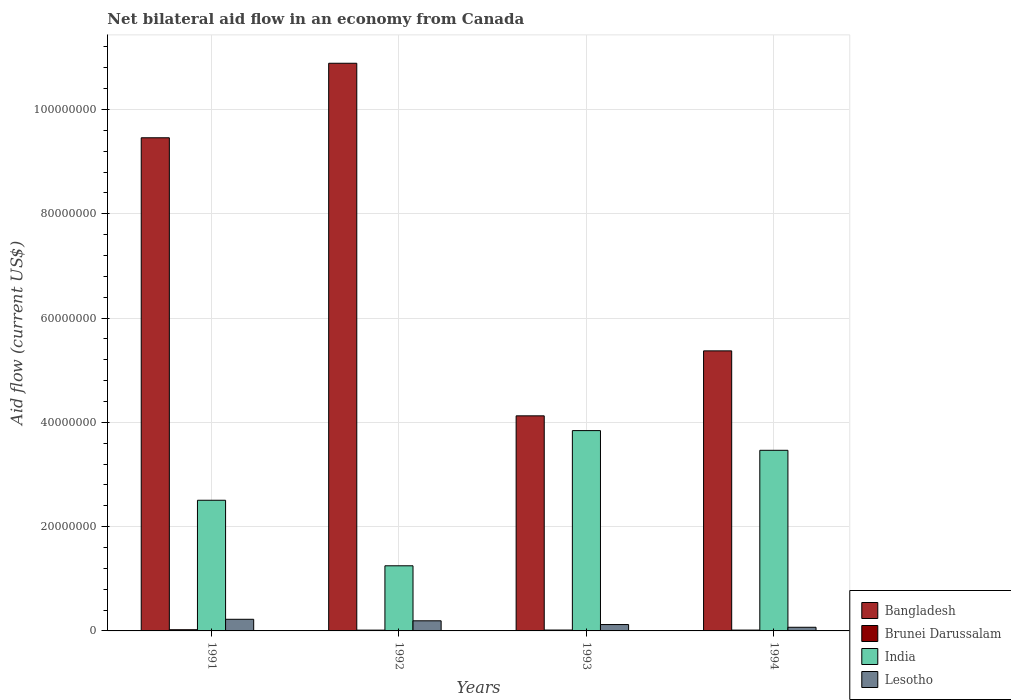How many different coloured bars are there?
Your answer should be very brief. 4. Are the number of bars per tick equal to the number of legend labels?
Ensure brevity in your answer.  Yes. How many bars are there on the 2nd tick from the right?
Make the answer very short. 4. What is the label of the 2nd group of bars from the left?
Provide a short and direct response. 1992. In how many cases, is the number of bars for a given year not equal to the number of legend labels?
Offer a terse response. 0. What is the net bilateral aid flow in Lesotho in 1993?
Provide a succinct answer. 1.22e+06. Across all years, what is the maximum net bilateral aid flow in Lesotho?
Offer a terse response. 2.23e+06. Across all years, what is the minimum net bilateral aid flow in Bangladesh?
Ensure brevity in your answer.  4.12e+07. In which year was the net bilateral aid flow in Bangladesh maximum?
Provide a succinct answer. 1992. What is the total net bilateral aid flow in Brunei Darussalam in the graph?
Provide a succinct answer. 7.10e+05. What is the difference between the net bilateral aid flow in Lesotho in 1991 and that in 1992?
Give a very brief answer. 2.90e+05. What is the difference between the net bilateral aid flow in Brunei Darussalam in 1993 and the net bilateral aid flow in Bangladesh in 1994?
Give a very brief answer. -5.35e+07. What is the average net bilateral aid flow in Bangladesh per year?
Give a very brief answer. 7.46e+07. In the year 1993, what is the difference between the net bilateral aid flow in Bangladesh and net bilateral aid flow in India?
Your answer should be compact. 2.83e+06. What is the ratio of the net bilateral aid flow in India in 1991 to that in 1992?
Your response must be concise. 2.01. What is the difference between the highest and the second highest net bilateral aid flow in Bangladesh?
Offer a terse response. 1.43e+07. What is the difference between the highest and the lowest net bilateral aid flow in Bangladesh?
Offer a terse response. 6.76e+07. Is the sum of the net bilateral aid flow in India in 1991 and 1994 greater than the maximum net bilateral aid flow in Lesotho across all years?
Provide a succinct answer. Yes. Is it the case that in every year, the sum of the net bilateral aid flow in Lesotho and net bilateral aid flow in Bangladesh is greater than the sum of net bilateral aid flow in Brunei Darussalam and net bilateral aid flow in India?
Offer a terse response. No. What does the 3rd bar from the right in 1991 represents?
Offer a very short reply. Brunei Darussalam. Are all the bars in the graph horizontal?
Provide a succinct answer. No. What is the difference between two consecutive major ticks on the Y-axis?
Your answer should be very brief. 2.00e+07. Does the graph contain any zero values?
Offer a terse response. No. Does the graph contain grids?
Offer a very short reply. Yes. Where does the legend appear in the graph?
Provide a short and direct response. Bottom right. What is the title of the graph?
Offer a very short reply. Net bilateral aid flow in an economy from Canada. What is the label or title of the X-axis?
Provide a succinct answer. Years. What is the label or title of the Y-axis?
Provide a succinct answer. Aid flow (current US$). What is the Aid flow (current US$) in Bangladesh in 1991?
Make the answer very short. 9.46e+07. What is the Aid flow (current US$) in Brunei Darussalam in 1991?
Provide a succinct answer. 2.30e+05. What is the Aid flow (current US$) in India in 1991?
Offer a terse response. 2.51e+07. What is the Aid flow (current US$) of Lesotho in 1991?
Keep it short and to the point. 2.23e+06. What is the Aid flow (current US$) of Bangladesh in 1992?
Your answer should be compact. 1.09e+08. What is the Aid flow (current US$) of Brunei Darussalam in 1992?
Keep it short and to the point. 1.50e+05. What is the Aid flow (current US$) in India in 1992?
Keep it short and to the point. 1.25e+07. What is the Aid flow (current US$) of Lesotho in 1992?
Your answer should be very brief. 1.94e+06. What is the Aid flow (current US$) in Bangladesh in 1993?
Make the answer very short. 4.12e+07. What is the Aid flow (current US$) of Brunei Darussalam in 1993?
Offer a very short reply. 1.70e+05. What is the Aid flow (current US$) in India in 1993?
Offer a terse response. 3.84e+07. What is the Aid flow (current US$) in Lesotho in 1993?
Offer a terse response. 1.22e+06. What is the Aid flow (current US$) of Bangladesh in 1994?
Offer a terse response. 5.37e+07. What is the Aid flow (current US$) of Brunei Darussalam in 1994?
Offer a terse response. 1.60e+05. What is the Aid flow (current US$) of India in 1994?
Offer a very short reply. 3.46e+07. Across all years, what is the maximum Aid flow (current US$) of Bangladesh?
Provide a short and direct response. 1.09e+08. Across all years, what is the maximum Aid flow (current US$) of India?
Make the answer very short. 3.84e+07. Across all years, what is the maximum Aid flow (current US$) of Lesotho?
Make the answer very short. 2.23e+06. Across all years, what is the minimum Aid flow (current US$) of Bangladesh?
Offer a terse response. 4.12e+07. Across all years, what is the minimum Aid flow (current US$) of Brunei Darussalam?
Your response must be concise. 1.50e+05. Across all years, what is the minimum Aid flow (current US$) in India?
Offer a terse response. 1.25e+07. What is the total Aid flow (current US$) of Bangladesh in the graph?
Provide a succinct answer. 2.98e+08. What is the total Aid flow (current US$) of Brunei Darussalam in the graph?
Your response must be concise. 7.10e+05. What is the total Aid flow (current US$) in India in the graph?
Give a very brief answer. 1.11e+08. What is the total Aid flow (current US$) of Lesotho in the graph?
Give a very brief answer. 6.09e+06. What is the difference between the Aid flow (current US$) in Bangladesh in 1991 and that in 1992?
Your answer should be compact. -1.43e+07. What is the difference between the Aid flow (current US$) of India in 1991 and that in 1992?
Give a very brief answer. 1.26e+07. What is the difference between the Aid flow (current US$) of Lesotho in 1991 and that in 1992?
Offer a very short reply. 2.90e+05. What is the difference between the Aid flow (current US$) in Bangladesh in 1991 and that in 1993?
Provide a short and direct response. 5.33e+07. What is the difference between the Aid flow (current US$) in Brunei Darussalam in 1991 and that in 1993?
Your answer should be very brief. 6.00e+04. What is the difference between the Aid flow (current US$) of India in 1991 and that in 1993?
Provide a short and direct response. -1.34e+07. What is the difference between the Aid flow (current US$) of Lesotho in 1991 and that in 1993?
Keep it short and to the point. 1.01e+06. What is the difference between the Aid flow (current US$) in Bangladesh in 1991 and that in 1994?
Your answer should be very brief. 4.09e+07. What is the difference between the Aid flow (current US$) of Brunei Darussalam in 1991 and that in 1994?
Your answer should be very brief. 7.00e+04. What is the difference between the Aid flow (current US$) of India in 1991 and that in 1994?
Your answer should be compact. -9.58e+06. What is the difference between the Aid flow (current US$) of Lesotho in 1991 and that in 1994?
Provide a short and direct response. 1.53e+06. What is the difference between the Aid flow (current US$) in Bangladesh in 1992 and that in 1993?
Give a very brief answer. 6.76e+07. What is the difference between the Aid flow (current US$) of Brunei Darussalam in 1992 and that in 1993?
Your answer should be very brief. -2.00e+04. What is the difference between the Aid flow (current US$) of India in 1992 and that in 1993?
Provide a succinct answer. -2.59e+07. What is the difference between the Aid flow (current US$) of Lesotho in 1992 and that in 1993?
Make the answer very short. 7.20e+05. What is the difference between the Aid flow (current US$) in Bangladesh in 1992 and that in 1994?
Make the answer very short. 5.52e+07. What is the difference between the Aid flow (current US$) in India in 1992 and that in 1994?
Offer a terse response. -2.22e+07. What is the difference between the Aid flow (current US$) of Lesotho in 1992 and that in 1994?
Offer a very short reply. 1.24e+06. What is the difference between the Aid flow (current US$) in Bangladesh in 1993 and that in 1994?
Your response must be concise. -1.25e+07. What is the difference between the Aid flow (current US$) in India in 1993 and that in 1994?
Offer a terse response. 3.78e+06. What is the difference between the Aid flow (current US$) in Lesotho in 1993 and that in 1994?
Keep it short and to the point. 5.20e+05. What is the difference between the Aid flow (current US$) in Bangladesh in 1991 and the Aid flow (current US$) in Brunei Darussalam in 1992?
Make the answer very short. 9.44e+07. What is the difference between the Aid flow (current US$) of Bangladesh in 1991 and the Aid flow (current US$) of India in 1992?
Provide a succinct answer. 8.21e+07. What is the difference between the Aid flow (current US$) in Bangladesh in 1991 and the Aid flow (current US$) in Lesotho in 1992?
Provide a short and direct response. 9.26e+07. What is the difference between the Aid flow (current US$) in Brunei Darussalam in 1991 and the Aid flow (current US$) in India in 1992?
Your answer should be compact. -1.23e+07. What is the difference between the Aid flow (current US$) in Brunei Darussalam in 1991 and the Aid flow (current US$) in Lesotho in 1992?
Provide a succinct answer. -1.71e+06. What is the difference between the Aid flow (current US$) in India in 1991 and the Aid flow (current US$) in Lesotho in 1992?
Make the answer very short. 2.31e+07. What is the difference between the Aid flow (current US$) of Bangladesh in 1991 and the Aid flow (current US$) of Brunei Darussalam in 1993?
Give a very brief answer. 9.44e+07. What is the difference between the Aid flow (current US$) in Bangladesh in 1991 and the Aid flow (current US$) in India in 1993?
Ensure brevity in your answer.  5.62e+07. What is the difference between the Aid flow (current US$) in Bangladesh in 1991 and the Aid flow (current US$) in Lesotho in 1993?
Provide a succinct answer. 9.34e+07. What is the difference between the Aid flow (current US$) in Brunei Darussalam in 1991 and the Aid flow (current US$) in India in 1993?
Your answer should be very brief. -3.82e+07. What is the difference between the Aid flow (current US$) in Brunei Darussalam in 1991 and the Aid flow (current US$) in Lesotho in 1993?
Make the answer very short. -9.90e+05. What is the difference between the Aid flow (current US$) of India in 1991 and the Aid flow (current US$) of Lesotho in 1993?
Ensure brevity in your answer.  2.38e+07. What is the difference between the Aid flow (current US$) in Bangladesh in 1991 and the Aid flow (current US$) in Brunei Darussalam in 1994?
Give a very brief answer. 9.44e+07. What is the difference between the Aid flow (current US$) in Bangladesh in 1991 and the Aid flow (current US$) in India in 1994?
Give a very brief answer. 5.99e+07. What is the difference between the Aid flow (current US$) of Bangladesh in 1991 and the Aid flow (current US$) of Lesotho in 1994?
Provide a succinct answer. 9.39e+07. What is the difference between the Aid flow (current US$) of Brunei Darussalam in 1991 and the Aid flow (current US$) of India in 1994?
Make the answer very short. -3.44e+07. What is the difference between the Aid flow (current US$) in Brunei Darussalam in 1991 and the Aid flow (current US$) in Lesotho in 1994?
Offer a terse response. -4.70e+05. What is the difference between the Aid flow (current US$) in India in 1991 and the Aid flow (current US$) in Lesotho in 1994?
Ensure brevity in your answer.  2.44e+07. What is the difference between the Aid flow (current US$) of Bangladesh in 1992 and the Aid flow (current US$) of Brunei Darussalam in 1993?
Make the answer very short. 1.09e+08. What is the difference between the Aid flow (current US$) of Bangladesh in 1992 and the Aid flow (current US$) of India in 1993?
Make the answer very short. 7.04e+07. What is the difference between the Aid flow (current US$) in Bangladesh in 1992 and the Aid flow (current US$) in Lesotho in 1993?
Your response must be concise. 1.08e+08. What is the difference between the Aid flow (current US$) in Brunei Darussalam in 1992 and the Aid flow (current US$) in India in 1993?
Provide a succinct answer. -3.83e+07. What is the difference between the Aid flow (current US$) of Brunei Darussalam in 1992 and the Aid flow (current US$) of Lesotho in 1993?
Make the answer very short. -1.07e+06. What is the difference between the Aid flow (current US$) in India in 1992 and the Aid flow (current US$) in Lesotho in 1993?
Give a very brief answer. 1.13e+07. What is the difference between the Aid flow (current US$) in Bangladesh in 1992 and the Aid flow (current US$) in Brunei Darussalam in 1994?
Your response must be concise. 1.09e+08. What is the difference between the Aid flow (current US$) in Bangladesh in 1992 and the Aid flow (current US$) in India in 1994?
Your answer should be very brief. 7.42e+07. What is the difference between the Aid flow (current US$) of Bangladesh in 1992 and the Aid flow (current US$) of Lesotho in 1994?
Ensure brevity in your answer.  1.08e+08. What is the difference between the Aid flow (current US$) in Brunei Darussalam in 1992 and the Aid flow (current US$) in India in 1994?
Offer a very short reply. -3.45e+07. What is the difference between the Aid flow (current US$) of Brunei Darussalam in 1992 and the Aid flow (current US$) of Lesotho in 1994?
Provide a succinct answer. -5.50e+05. What is the difference between the Aid flow (current US$) in India in 1992 and the Aid flow (current US$) in Lesotho in 1994?
Ensure brevity in your answer.  1.18e+07. What is the difference between the Aid flow (current US$) of Bangladesh in 1993 and the Aid flow (current US$) of Brunei Darussalam in 1994?
Your answer should be compact. 4.11e+07. What is the difference between the Aid flow (current US$) in Bangladesh in 1993 and the Aid flow (current US$) in India in 1994?
Your answer should be compact. 6.61e+06. What is the difference between the Aid flow (current US$) of Bangladesh in 1993 and the Aid flow (current US$) of Lesotho in 1994?
Provide a succinct answer. 4.06e+07. What is the difference between the Aid flow (current US$) of Brunei Darussalam in 1993 and the Aid flow (current US$) of India in 1994?
Offer a very short reply. -3.45e+07. What is the difference between the Aid flow (current US$) of Brunei Darussalam in 1993 and the Aid flow (current US$) of Lesotho in 1994?
Give a very brief answer. -5.30e+05. What is the difference between the Aid flow (current US$) in India in 1993 and the Aid flow (current US$) in Lesotho in 1994?
Give a very brief answer. 3.77e+07. What is the average Aid flow (current US$) in Bangladesh per year?
Your answer should be compact. 7.46e+07. What is the average Aid flow (current US$) in Brunei Darussalam per year?
Provide a succinct answer. 1.78e+05. What is the average Aid flow (current US$) of India per year?
Provide a short and direct response. 2.77e+07. What is the average Aid flow (current US$) of Lesotho per year?
Offer a very short reply. 1.52e+06. In the year 1991, what is the difference between the Aid flow (current US$) in Bangladesh and Aid flow (current US$) in Brunei Darussalam?
Keep it short and to the point. 9.44e+07. In the year 1991, what is the difference between the Aid flow (current US$) of Bangladesh and Aid flow (current US$) of India?
Offer a terse response. 6.95e+07. In the year 1991, what is the difference between the Aid flow (current US$) of Bangladesh and Aid flow (current US$) of Lesotho?
Offer a very short reply. 9.24e+07. In the year 1991, what is the difference between the Aid flow (current US$) of Brunei Darussalam and Aid flow (current US$) of India?
Offer a terse response. -2.48e+07. In the year 1991, what is the difference between the Aid flow (current US$) of Brunei Darussalam and Aid flow (current US$) of Lesotho?
Provide a succinct answer. -2.00e+06. In the year 1991, what is the difference between the Aid flow (current US$) of India and Aid flow (current US$) of Lesotho?
Provide a short and direct response. 2.28e+07. In the year 1992, what is the difference between the Aid flow (current US$) of Bangladesh and Aid flow (current US$) of Brunei Darussalam?
Offer a terse response. 1.09e+08. In the year 1992, what is the difference between the Aid flow (current US$) in Bangladesh and Aid flow (current US$) in India?
Give a very brief answer. 9.64e+07. In the year 1992, what is the difference between the Aid flow (current US$) of Bangladesh and Aid flow (current US$) of Lesotho?
Ensure brevity in your answer.  1.07e+08. In the year 1992, what is the difference between the Aid flow (current US$) of Brunei Darussalam and Aid flow (current US$) of India?
Your answer should be very brief. -1.23e+07. In the year 1992, what is the difference between the Aid flow (current US$) of Brunei Darussalam and Aid flow (current US$) of Lesotho?
Keep it short and to the point. -1.79e+06. In the year 1992, what is the difference between the Aid flow (current US$) of India and Aid flow (current US$) of Lesotho?
Provide a short and direct response. 1.06e+07. In the year 1993, what is the difference between the Aid flow (current US$) of Bangladesh and Aid flow (current US$) of Brunei Darussalam?
Give a very brief answer. 4.11e+07. In the year 1993, what is the difference between the Aid flow (current US$) in Bangladesh and Aid flow (current US$) in India?
Your answer should be compact. 2.83e+06. In the year 1993, what is the difference between the Aid flow (current US$) of Bangladesh and Aid flow (current US$) of Lesotho?
Make the answer very short. 4.00e+07. In the year 1993, what is the difference between the Aid flow (current US$) of Brunei Darussalam and Aid flow (current US$) of India?
Your response must be concise. -3.82e+07. In the year 1993, what is the difference between the Aid flow (current US$) of Brunei Darussalam and Aid flow (current US$) of Lesotho?
Offer a very short reply. -1.05e+06. In the year 1993, what is the difference between the Aid flow (current US$) in India and Aid flow (current US$) in Lesotho?
Make the answer very short. 3.72e+07. In the year 1994, what is the difference between the Aid flow (current US$) of Bangladesh and Aid flow (current US$) of Brunei Darussalam?
Provide a succinct answer. 5.36e+07. In the year 1994, what is the difference between the Aid flow (current US$) in Bangladesh and Aid flow (current US$) in India?
Your answer should be very brief. 1.91e+07. In the year 1994, what is the difference between the Aid flow (current US$) of Bangladesh and Aid flow (current US$) of Lesotho?
Offer a very short reply. 5.30e+07. In the year 1994, what is the difference between the Aid flow (current US$) in Brunei Darussalam and Aid flow (current US$) in India?
Provide a succinct answer. -3.45e+07. In the year 1994, what is the difference between the Aid flow (current US$) in Brunei Darussalam and Aid flow (current US$) in Lesotho?
Your answer should be very brief. -5.40e+05. In the year 1994, what is the difference between the Aid flow (current US$) of India and Aid flow (current US$) of Lesotho?
Give a very brief answer. 3.39e+07. What is the ratio of the Aid flow (current US$) in Bangladesh in 1991 to that in 1992?
Provide a short and direct response. 0.87. What is the ratio of the Aid flow (current US$) in Brunei Darussalam in 1991 to that in 1992?
Offer a terse response. 1.53. What is the ratio of the Aid flow (current US$) in India in 1991 to that in 1992?
Offer a terse response. 2.01. What is the ratio of the Aid flow (current US$) of Lesotho in 1991 to that in 1992?
Provide a short and direct response. 1.15. What is the ratio of the Aid flow (current US$) in Bangladesh in 1991 to that in 1993?
Give a very brief answer. 2.29. What is the ratio of the Aid flow (current US$) of Brunei Darussalam in 1991 to that in 1993?
Offer a terse response. 1.35. What is the ratio of the Aid flow (current US$) of India in 1991 to that in 1993?
Give a very brief answer. 0.65. What is the ratio of the Aid flow (current US$) in Lesotho in 1991 to that in 1993?
Your answer should be compact. 1.83. What is the ratio of the Aid flow (current US$) in Bangladesh in 1991 to that in 1994?
Give a very brief answer. 1.76. What is the ratio of the Aid flow (current US$) in Brunei Darussalam in 1991 to that in 1994?
Give a very brief answer. 1.44. What is the ratio of the Aid flow (current US$) of India in 1991 to that in 1994?
Ensure brevity in your answer.  0.72. What is the ratio of the Aid flow (current US$) in Lesotho in 1991 to that in 1994?
Provide a short and direct response. 3.19. What is the ratio of the Aid flow (current US$) in Bangladesh in 1992 to that in 1993?
Your response must be concise. 2.64. What is the ratio of the Aid flow (current US$) in Brunei Darussalam in 1992 to that in 1993?
Keep it short and to the point. 0.88. What is the ratio of the Aid flow (current US$) of India in 1992 to that in 1993?
Your answer should be compact. 0.33. What is the ratio of the Aid flow (current US$) in Lesotho in 1992 to that in 1993?
Your answer should be very brief. 1.59. What is the ratio of the Aid flow (current US$) of Bangladesh in 1992 to that in 1994?
Make the answer very short. 2.03. What is the ratio of the Aid flow (current US$) in Brunei Darussalam in 1992 to that in 1994?
Offer a terse response. 0.94. What is the ratio of the Aid flow (current US$) of India in 1992 to that in 1994?
Your answer should be very brief. 0.36. What is the ratio of the Aid flow (current US$) of Lesotho in 1992 to that in 1994?
Give a very brief answer. 2.77. What is the ratio of the Aid flow (current US$) in Bangladesh in 1993 to that in 1994?
Provide a short and direct response. 0.77. What is the ratio of the Aid flow (current US$) in Brunei Darussalam in 1993 to that in 1994?
Ensure brevity in your answer.  1.06. What is the ratio of the Aid flow (current US$) in India in 1993 to that in 1994?
Offer a terse response. 1.11. What is the ratio of the Aid flow (current US$) in Lesotho in 1993 to that in 1994?
Offer a very short reply. 1.74. What is the difference between the highest and the second highest Aid flow (current US$) in Bangladesh?
Your answer should be very brief. 1.43e+07. What is the difference between the highest and the second highest Aid flow (current US$) of Brunei Darussalam?
Your response must be concise. 6.00e+04. What is the difference between the highest and the second highest Aid flow (current US$) in India?
Ensure brevity in your answer.  3.78e+06. What is the difference between the highest and the lowest Aid flow (current US$) of Bangladesh?
Your answer should be compact. 6.76e+07. What is the difference between the highest and the lowest Aid flow (current US$) in India?
Offer a terse response. 2.59e+07. What is the difference between the highest and the lowest Aid flow (current US$) in Lesotho?
Provide a succinct answer. 1.53e+06. 